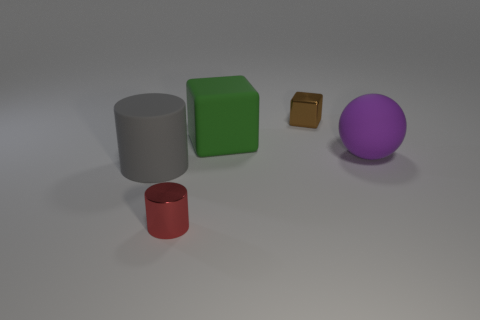Add 5 gray rubber cubes. How many objects exist? 10 Subtract all balls. How many objects are left? 4 Add 3 blue spheres. How many blue spheres exist? 3 Subtract 0 purple cubes. How many objects are left? 5 Subtract all small gray rubber blocks. Subtract all green matte blocks. How many objects are left? 4 Add 4 large things. How many large things are left? 7 